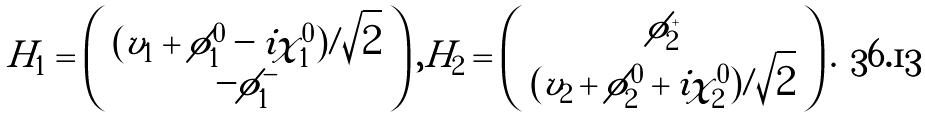<formula> <loc_0><loc_0><loc_500><loc_500>H _ { 1 } = \left ( \begin{array} { c } ( v _ { 1 } + \phi _ { 1 } ^ { 0 } - i \chi _ { 1 } ^ { 0 } ) / \sqrt { 2 } \\ - \phi _ { 1 } ^ { - } \end{array} \right ) , H _ { 2 } = \left ( \begin{array} { c } \phi _ { 2 } ^ { + } \\ ( v _ { 2 } + \phi _ { 2 } ^ { 0 } + i \chi _ { 2 } ^ { 0 } ) / \sqrt { 2 } \end{array} \right ) .</formula> 